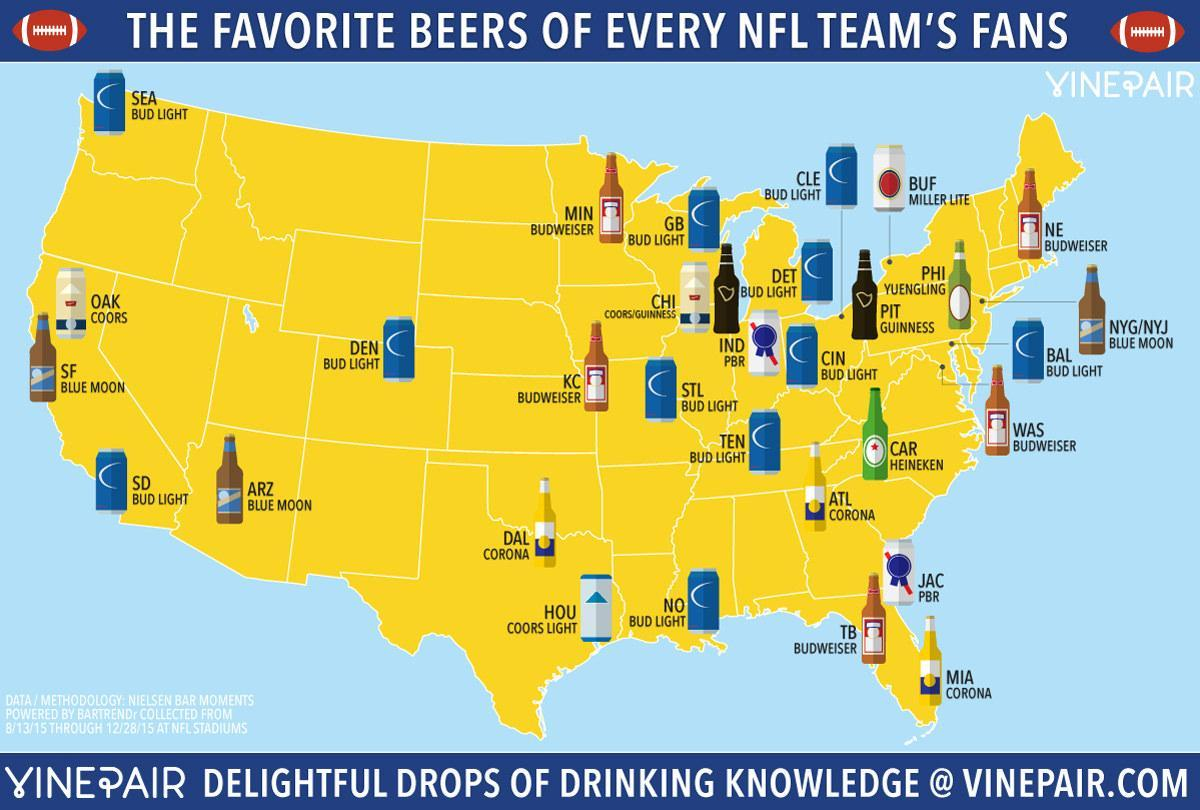How many team's fans have Corona as their favorite beer?
Answer the question with a short phrase. 3 How many NFL team's fans prefer Bud Light? 11 Which brand is the favorite of 5 NFL team's fans? Budweiser From the infographic, which is the second-most preferred brand of beer by NFL team fans? Budweiser From the infographic, which is the most preferred brand of beer by NFL team fans? Bud Light How many team's fans like the beer Heineken? 1 